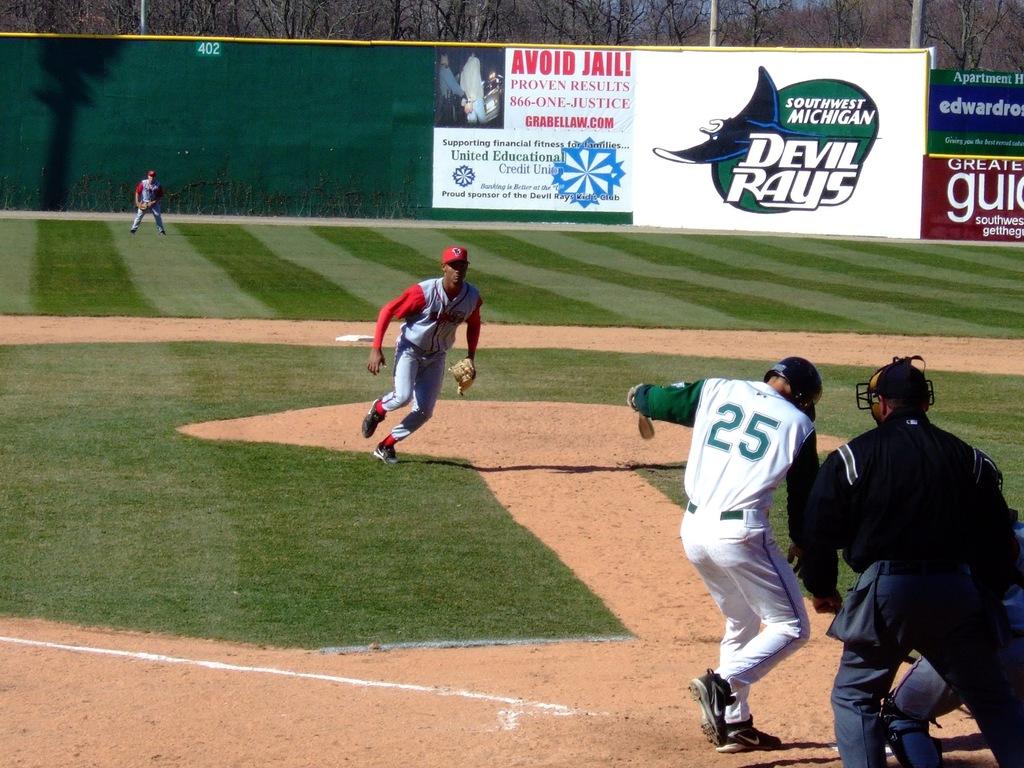What state do the devil rays play in?
Your response must be concise. Michigan. 